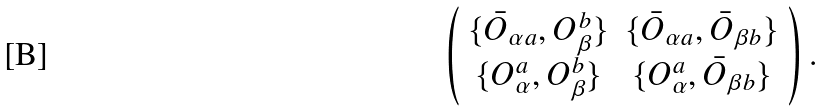<formula> <loc_0><loc_0><loc_500><loc_500>\left ( \begin{array} { c c } \{ \bar { O } _ { \alpha a } , O ^ { b } _ { \beta } \} & \{ \bar { O } _ { \alpha a } , \bar { O } _ { \beta b } \} \\ \{ O ^ { a } _ { \alpha } , O ^ { b } _ { \beta } \} & \{ O ^ { a } _ { \alpha } , \bar { O } _ { \beta b } \} \end{array} \right ) .</formula> 